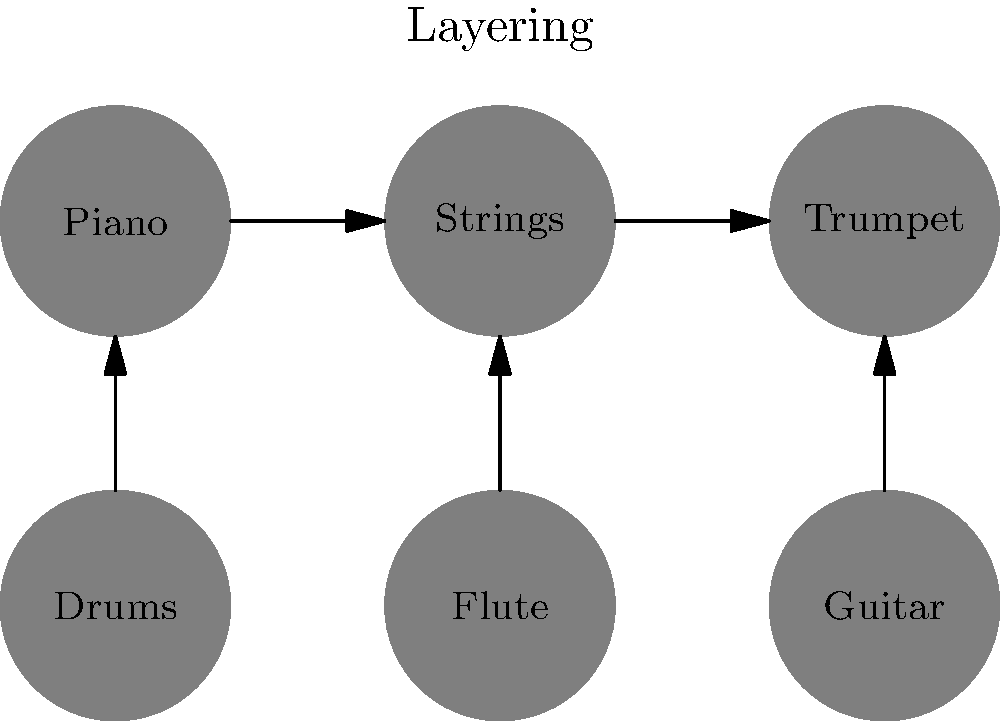In Burt Bacharach's iconic instrumental arrangements, which instrument typically serves as the foundation, and how does he build upon it to create his signature sound? To understand Burt Bacharach's instrumental arrangement technique, let's break it down step-by-step:

1. Foundation: Bacharach typically starts with the piano as the foundational instrument. The piano provides both harmonic structure and rhythmic drive.

2. Strings: He often layers strings on top of the piano. These add warmth and depth to the arrangement, filling out the mid-range frequencies.

3. Brass (Trumpet): Bacharach is known for his distinctive use of trumpet, which often carries the melody or provides counterpoint to the vocal line.

4. Percussion: Drums are added to enhance the rhythmic element, but Bacharach often uses them sparingly or in unconventional patterns.

5. Woodwinds (Flute): Flutes and other woodwinds are frequently used for melodic embellishments and to add a light, airy quality to the arrangement.

6. Guitar: While not always present, guitar is sometimes used to add texture or rhythmic elements.

The key to Bacharach's sound is the way he layers these instruments. He starts with the piano foundation, then carefully adds each instrument to create a rich, complex arrangement without overcrowding the sound. This layering technique, combined with his unique chord progressions and time signatures, results in his signature sophisticated pop sound.
Answer: Piano, with layered instruments building complexity 